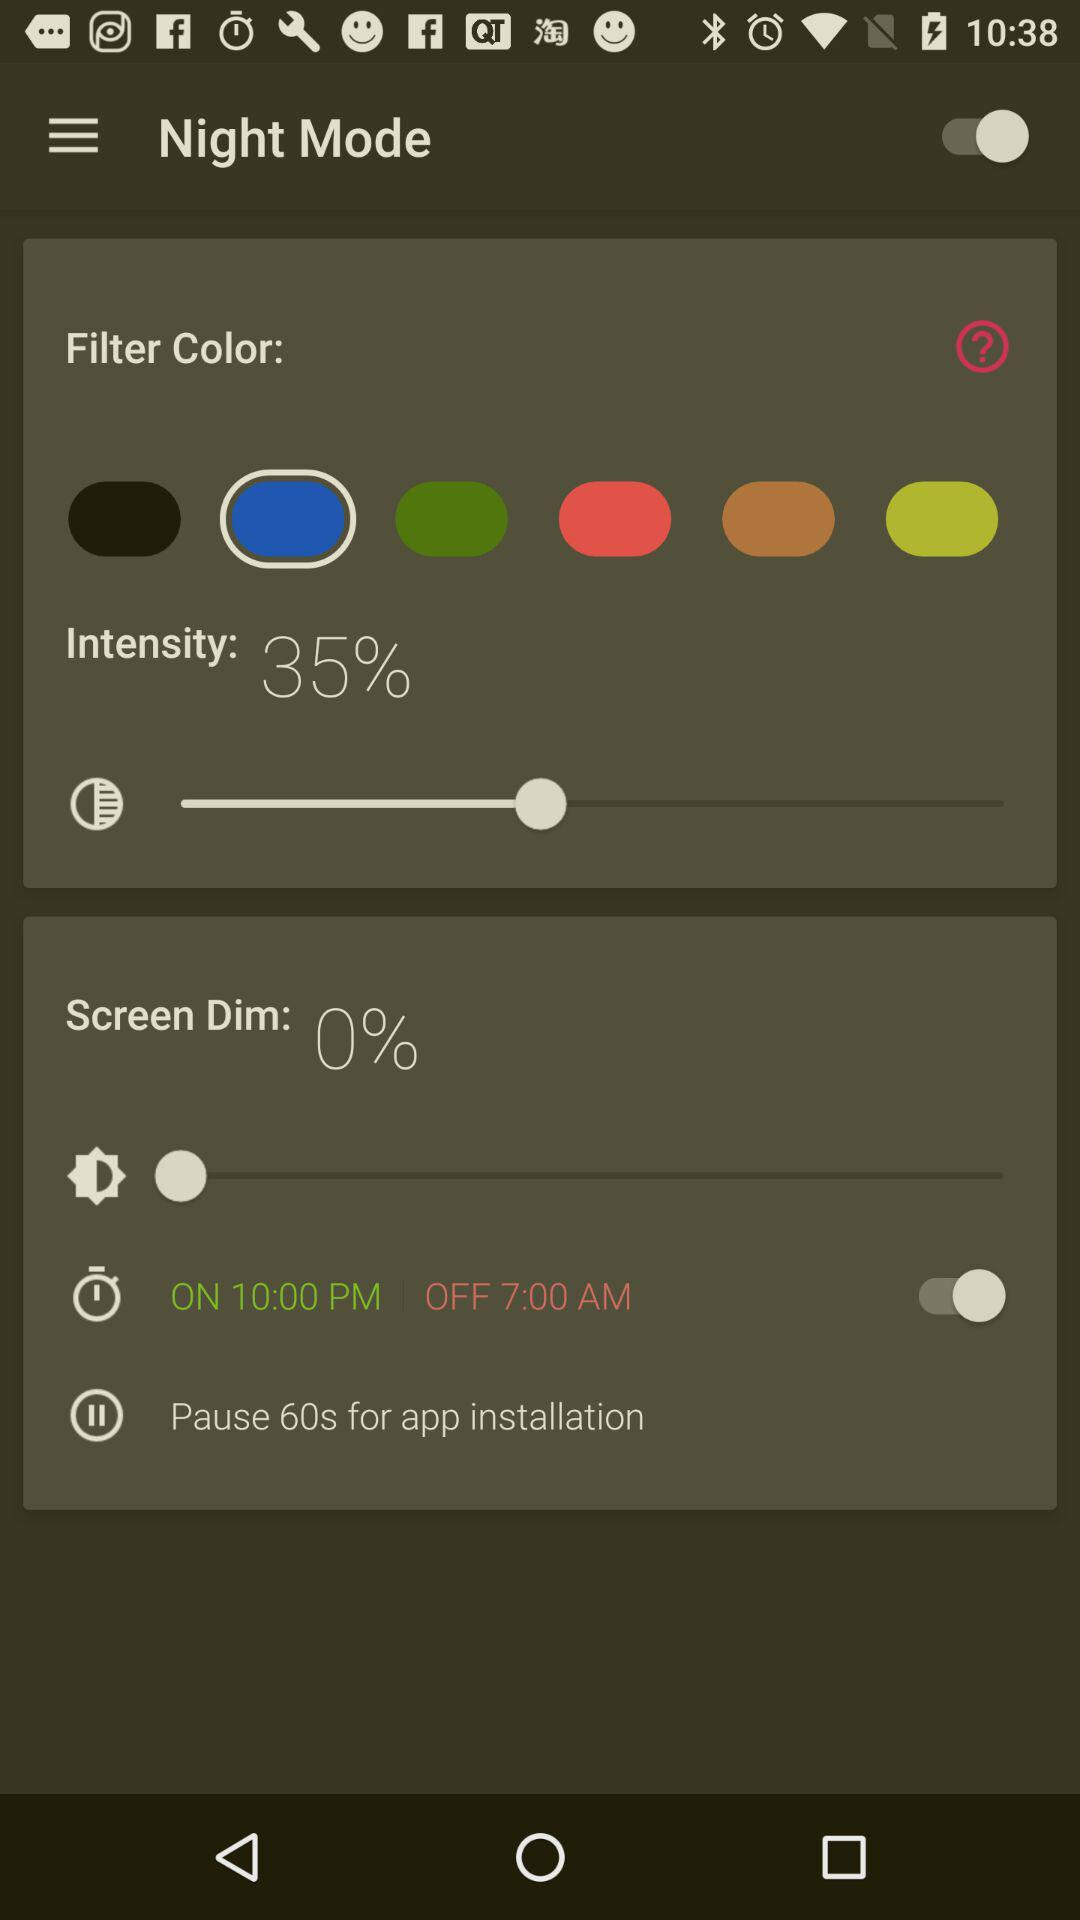What's the "OFF" time? The "OFF" time is 7 a.m. 